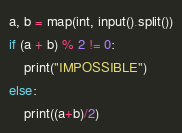<code> <loc_0><loc_0><loc_500><loc_500><_Python_>a, b = map(int, input().split())
if (a + b) % 2 != 0:
    print("IMPOSSIBLE")
else:
    print((a+b)/2)</code> 